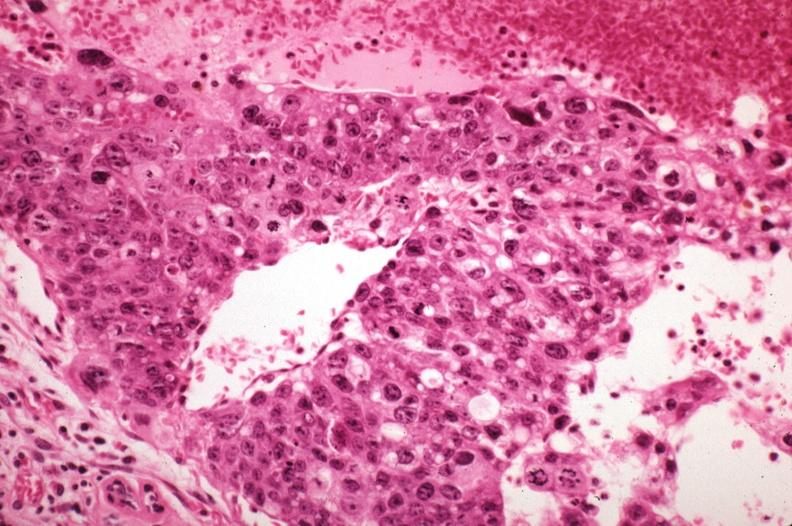where is this area in the body?
Answer the question using a single word or phrase. Breast 